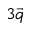<formula> <loc_0><loc_0><loc_500><loc_500>3 \vec { q }</formula> 